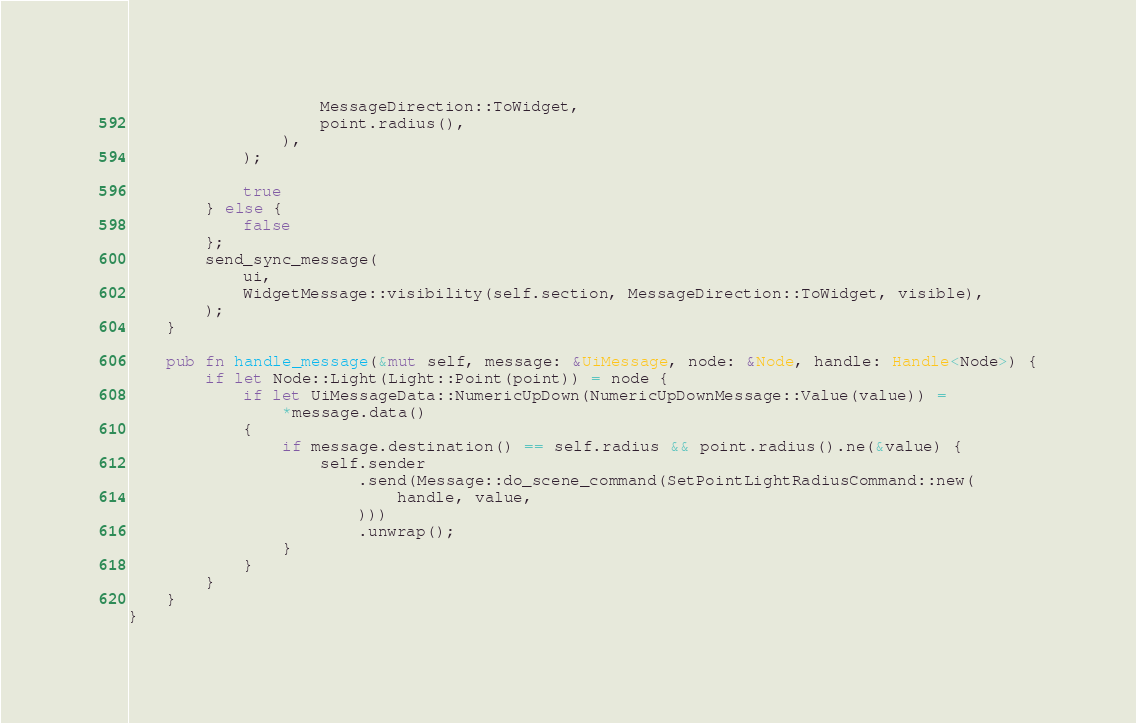Convert code to text. <code><loc_0><loc_0><loc_500><loc_500><_Rust_>                    MessageDirection::ToWidget,
                    point.radius(),
                ),
            );

            true
        } else {
            false
        };
        send_sync_message(
            ui,
            WidgetMessage::visibility(self.section, MessageDirection::ToWidget, visible),
        );
    }

    pub fn handle_message(&mut self, message: &UiMessage, node: &Node, handle: Handle<Node>) {
        if let Node::Light(Light::Point(point)) = node {
            if let UiMessageData::NumericUpDown(NumericUpDownMessage::Value(value)) =
                *message.data()
            {
                if message.destination() == self.radius && point.radius().ne(&value) {
                    self.sender
                        .send(Message::do_scene_command(SetPointLightRadiusCommand::new(
                            handle, value,
                        )))
                        .unwrap();
                }
            }
        }
    }
}
</code> 